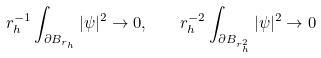Convert formula to latex. <formula><loc_0><loc_0><loc_500><loc_500>r _ { h } ^ { - 1 } \int _ { \partial B _ { r _ { h } } } | \psi | ^ { 2 } \to 0 , \quad r _ { h } ^ { - 2 } \int _ { \partial B _ { r _ { h } ^ { 2 } } } | \psi | ^ { 2 } \to 0</formula> 